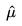<formula> <loc_0><loc_0><loc_500><loc_500>\hat { \mu }</formula> 